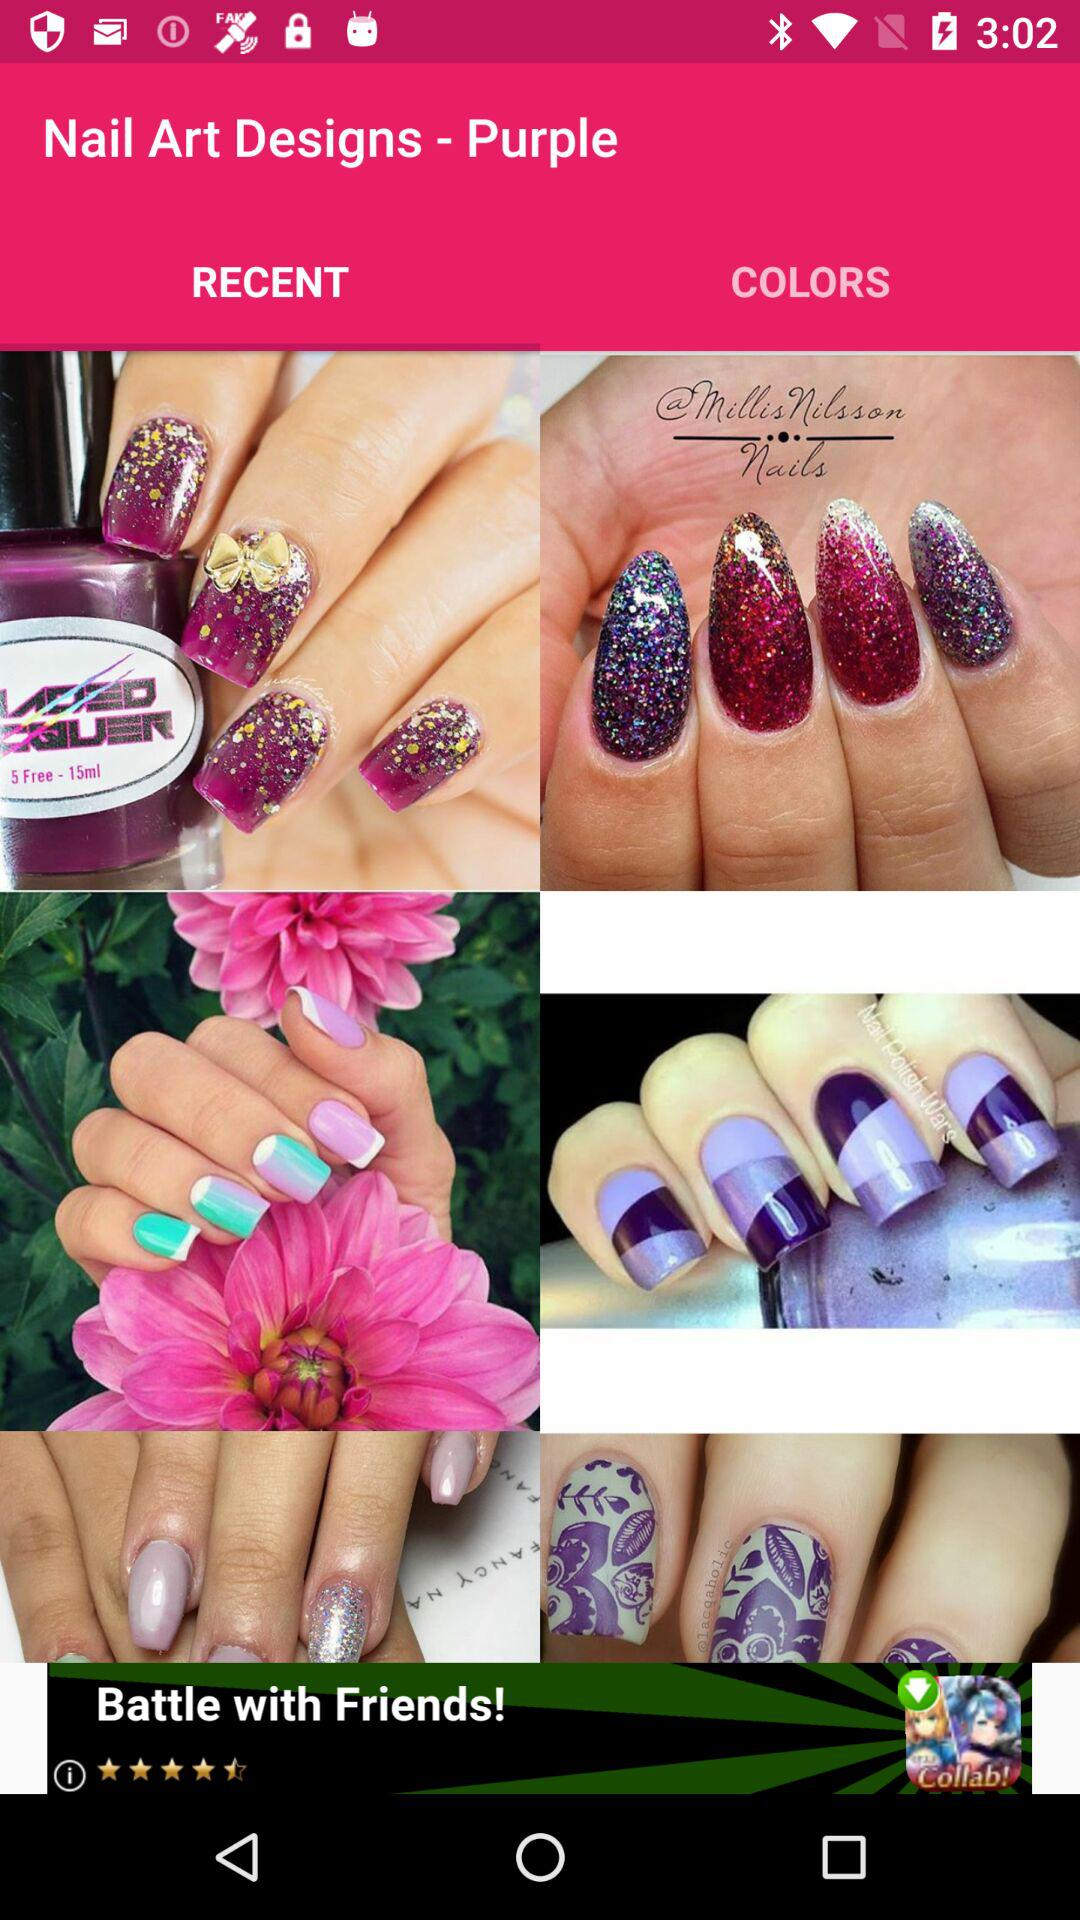Which tab am I on? You are on the "RECENT" tab. 